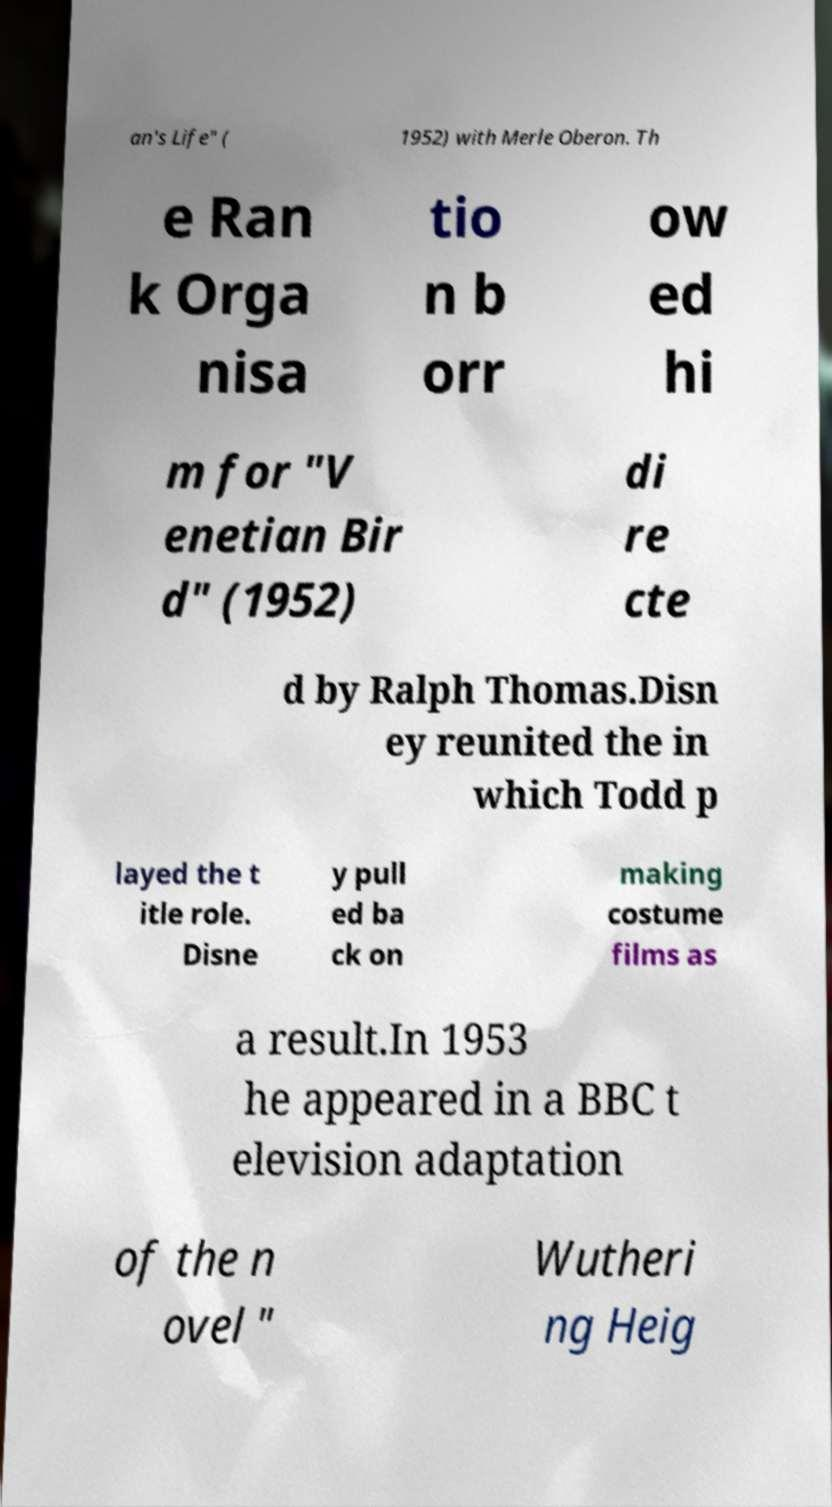Can you read and provide the text displayed in the image?This photo seems to have some interesting text. Can you extract and type it out for me? an's Life" ( 1952) with Merle Oberon. Th e Ran k Orga nisa tio n b orr ow ed hi m for "V enetian Bir d" (1952) di re cte d by Ralph Thomas.Disn ey reunited the in which Todd p layed the t itle role. Disne y pull ed ba ck on making costume films as a result.In 1953 he appeared in a BBC t elevision adaptation of the n ovel " Wutheri ng Heig 